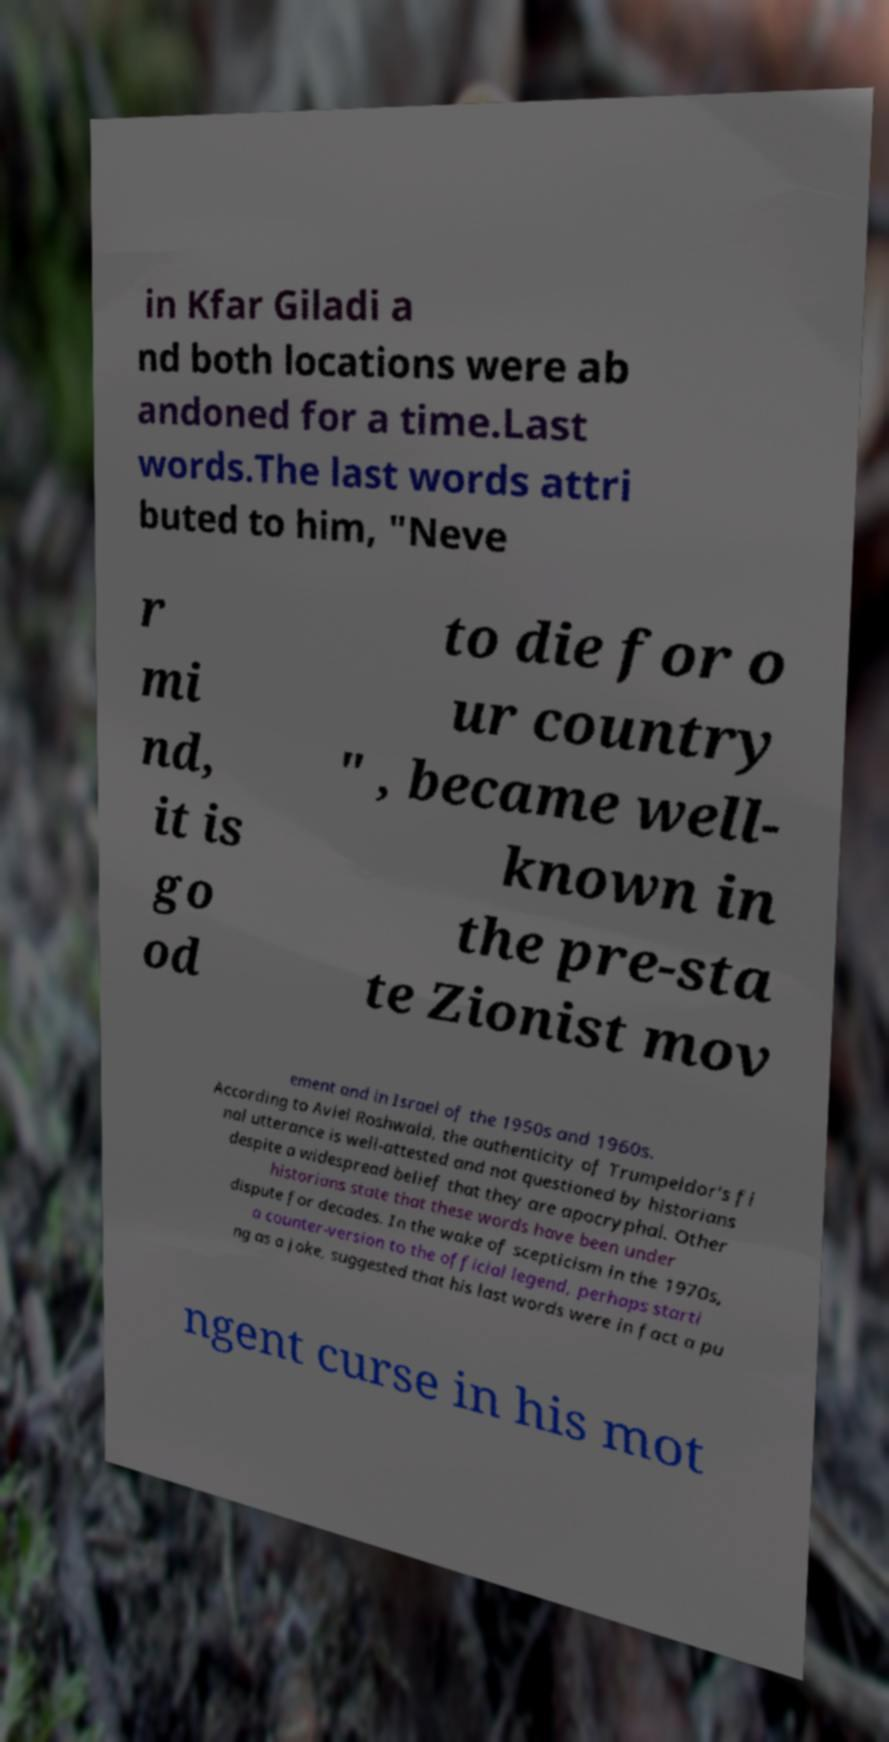What messages or text are displayed in this image? I need them in a readable, typed format. in Kfar Giladi a nd both locations were ab andoned for a time.Last words.The last words attri buted to him, "Neve r mi nd, it is go od to die for o ur country " , became well- known in the pre-sta te Zionist mov ement and in Israel of the 1950s and 1960s. According to Aviel Roshwald, the authenticity of Trumpeldor's fi nal utterance is well-attested and not questioned by historians despite a widespread belief that they are apocryphal. Other historians state that these words have been under dispute for decades. In the wake of scepticism in the 1970s, a counter-version to the official legend, perhaps starti ng as a joke, suggested that his last words were in fact a pu ngent curse in his mot 